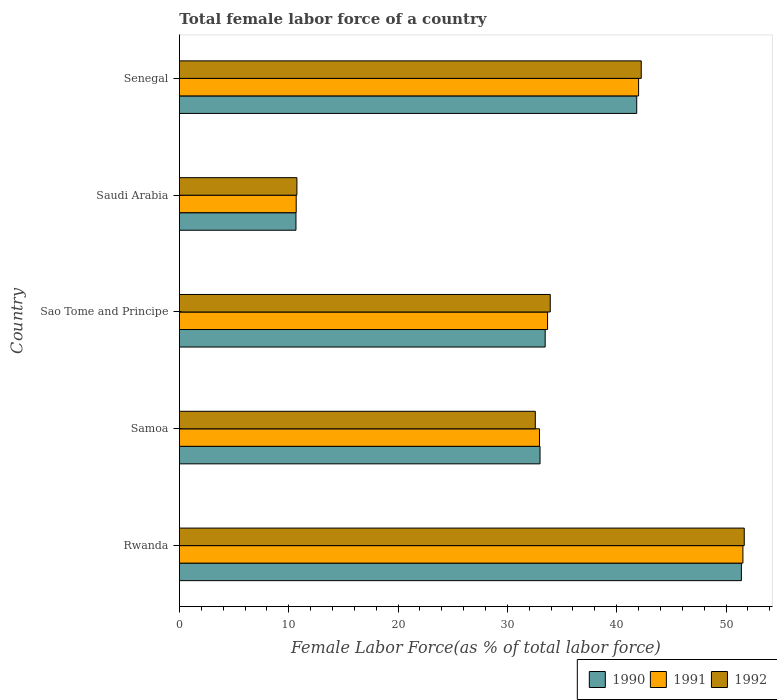How many different coloured bars are there?
Provide a short and direct response. 3. Are the number of bars per tick equal to the number of legend labels?
Your response must be concise. Yes. Are the number of bars on each tick of the Y-axis equal?
Your answer should be compact. Yes. What is the label of the 3rd group of bars from the top?
Ensure brevity in your answer.  Sao Tome and Principe. What is the percentage of female labor force in 1991 in Samoa?
Give a very brief answer. 32.94. Across all countries, what is the maximum percentage of female labor force in 1991?
Offer a very short reply. 51.55. Across all countries, what is the minimum percentage of female labor force in 1992?
Ensure brevity in your answer.  10.75. In which country was the percentage of female labor force in 1990 maximum?
Your answer should be very brief. Rwanda. In which country was the percentage of female labor force in 1992 minimum?
Your answer should be compact. Saudi Arabia. What is the total percentage of female labor force in 1992 in the graph?
Give a very brief answer. 171.13. What is the difference between the percentage of female labor force in 1991 in Samoa and that in Sao Tome and Principe?
Keep it short and to the point. -0.74. What is the difference between the percentage of female labor force in 1990 in Rwanda and the percentage of female labor force in 1992 in Samoa?
Your response must be concise. 18.85. What is the average percentage of female labor force in 1990 per country?
Offer a very short reply. 34.07. What is the difference between the percentage of female labor force in 1991 and percentage of female labor force in 1990 in Sao Tome and Principe?
Give a very brief answer. 0.22. In how many countries, is the percentage of female labor force in 1990 greater than 22 %?
Provide a short and direct response. 4. What is the ratio of the percentage of female labor force in 1991 in Samoa to that in Sao Tome and Principe?
Provide a succinct answer. 0.98. What is the difference between the highest and the second highest percentage of female labor force in 1991?
Offer a very short reply. 9.54. What is the difference between the highest and the lowest percentage of female labor force in 1990?
Keep it short and to the point. 40.74. In how many countries, is the percentage of female labor force in 1991 greater than the average percentage of female labor force in 1991 taken over all countries?
Offer a very short reply. 2. Is the sum of the percentage of female labor force in 1990 in Rwanda and Saudi Arabia greater than the maximum percentage of female labor force in 1991 across all countries?
Your answer should be compact. Yes. How many bars are there?
Offer a very short reply. 15. How many countries are there in the graph?
Provide a short and direct response. 5. What is the difference between two consecutive major ticks on the X-axis?
Provide a succinct answer. 10. What is the title of the graph?
Your response must be concise. Total female labor force of a country. Does "1983" appear as one of the legend labels in the graph?
Provide a short and direct response. No. What is the label or title of the X-axis?
Your answer should be compact. Female Labor Force(as % of total labor force). What is the Female Labor Force(as % of total labor force) in 1990 in Rwanda?
Your answer should be compact. 51.4. What is the Female Labor Force(as % of total labor force) in 1991 in Rwanda?
Your response must be concise. 51.55. What is the Female Labor Force(as % of total labor force) of 1992 in Rwanda?
Offer a terse response. 51.67. What is the Female Labor Force(as % of total labor force) of 1990 in Samoa?
Keep it short and to the point. 32.99. What is the Female Labor Force(as % of total labor force) of 1991 in Samoa?
Your answer should be compact. 32.94. What is the Female Labor Force(as % of total labor force) of 1992 in Samoa?
Keep it short and to the point. 32.55. What is the Female Labor Force(as % of total labor force) in 1990 in Sao Tome and Principe?
Your answer should be very brief. 33.46. What is the Female Labor Force(as % of total labor force) of 1991 in Sao Tome and Principe?
Your response must be concise. 33.67. What is the Female Labor Force(as % of total labor force) of 1992 in Sao Tome and Principe?
Offer a very short reply. 33.92. What is the Female Labor Force(as % of total labor force) of 1990 in Saudi Arabia?
Offer a terse response. 10.66. What is the Female Labor Force(as % of total labor force) of 1991 in Saudi Arabia?
Give a very brief answer. 10.68. What is the Female Labor Force(as % of total labor force) of 1992 in Saudi Arabia?
Provide a short and direct response. 10.75. What is the Female Labor Force(as % of total labor force) of 1990 in Senegal?
Your response must be concise. 41.83. What is the Female Labor Force(as % of total labor force) of 1991 in Senegal?
Your answer should be compact. 42. What is the Female Labor Force(as % of total labor force) in 1992 in Senegal?
Ensure brevity in your answer.  42.24. Across all countries, what is the maximum Female Labor Force(as % of total labor force) in 1990?
Offer a terse response. 51.4. Across all countries, what is the maximum Female Labor Force(as % of total labor force) of 1991?
Your response must be concise. 51.55. Across all countries, what is the maximum Female Labor Force(as % of total labor force) of 1992?
Provide a succinct answer. 51.67. Across all countries, what is the minimum Female Labor Force(as % of total labor force) in 1990?
Ensure brevity in your answer.  10.66. Across all countries, what is the minimum Female Labor Force(as % of total labor force) in 1991?
Your response must be concise. 10.68. Across all countries, what is the minimum Female Labor Force(as % of total labor force) in 1992?
Offer a terse response. 10.75. What is the total Female Labor Force(as % of total labor force) of 1990 in the graph?
Your response must be concise. 170.34. What is the total Female Labor Force(as % of total labor force) of 1991 in the graph?
Your answer should be compact. 170.84. What is the total Female Labor Force(as % of total labor force) of 1992 in the graph?
Ensure brevity in your answer.  171.13. What is the difference between the Female Labor Force(as % of total labor force) of 1990 in Rwanda and that in Samoa?
Provide a succinct answer. 18.42. What is the difference between the Female Labor Force(as % of total labor force) in 1991 in Rwanda and that in Samoa?
Your answer should be very brief. 18.61. What is the difference between the Female Labor Force(as % of total labor force) of 1992 in Rwanda and that in Samoa?
Provide a short and direct response. 19.11. What is the difference between the Female Labor Force(as % of total labor force) of 1990 in Rwanda and that in Sao Tome and Principe?
Provide a succinct answer. 17.95. What is the difference between the Female Labor Force(as % of total labor force) in 1991 in Rwanda and that in Sao Tome and Principe?
Provide a succinct answer. 17.87. What is the difference between the Female Labor Force(as % of total labor force) in 1992 in Rwanda and that in Sao Tome and Principe?
Your response must be concise. 17.75. What is the difference between the Female Labor Force(as % of total labor force) of 1990 in Rwanda and that in Saudi Arabia?
Your answer should be compact. 40.74. What is the difference between the Female Labor Force(as % of total labor force) of 1991 in Rwanda and that in Saudi Arabia?
Give a very brief answer. 40.86. What is the difference between the Female Labor Force(as % of total labor force) of 1992 in Rwanda and that in Saudi Arabia?
Keep it short and to the point. 40.92. What is the difference between the Female Labor Force(as % of total labor force) of 1990 in Rwanda and that in Senegal?
Offer a terse response. 9.57. What is the difference between the Female Labor Force(as % of total labor force) in 1991 in Rwanda and that in Senegal?
Provide a short and direct response. 9.54. What is the difference between the Female Labor Force(as % of total labor force) in 1992 in Rwanda and that in Senegal?
Ensure brevity in your answer.  9.42. What is the difference between the Female Labor Force(as % of total labor force) in 1990 in Samoa and that in Sao Tome and Principe?
Your response must be concise. -0.47. What is the difference between the Female Labor Force(as % of total labor force) of 1991 in Samoa and that in Sao Tome and Principe?
Your response must be concise. -0.74. What is the difference between the Female Labor Force(as % of total labor force) of 1992 in Samoa and that in Sao Tome and Principe?
Give a very brief answer. -1.37. What is the difference between the Female Labor Force(as % of total labor force) in 1990 in Samoa and that in Saudi Arabia?
Your response must be concise. 22.32. What is the difference between the Female Labor Force(as % of total labor force) in 1991 in Samoa and that in Saudi Arabia?
Your response must be concise. 22.26. What is the difference between the Female Labor Force(as % of total labor force) in 1992 in Samoa and that in Saudi Arabia?
Ensure brevity in your answer.  21.81. What is the difference between the Female Labor Force(as % of total labor force) of 1990 in Samoa and that in Senegal?
Make the answer very short. -8.85. What is the difference between the Female Labor Force(as % of total labor force) in 1991 in Samoa and that in Senegal?
Provide a short and direct response. -9.06. What is the difference between the Female Labor Force(as % of total labor force) of 1992 in Samoa and that in Senegal?
Ensure brevity in your answer.  -9.69. What is the difference between the Female Labor Force(as % of total labor force) of 1990 in Sao Tome and Principe and that in Saudi Arabia?
Ensure brevity in your answer.  22.79. What is the difference between the Female Labor Force(as % of total labor force) of 1991 in Sao Tome and Principe and that in Saudi Arabia?
Offer a terse response. 22.99. What is the difference between the Female Labor Force(as % of total labor force) of 1992 in Sao Tome and Principe and that in Saudi Arabia?
Your response must be concise. 23.17. What is the difference between the Female Labor Force(as % of total labor force) of 1990 in Sao Tome and Principe and that in Senegal?
Make the answer very short. -8.38. What is the difference between the Female Labor Force(as % of total labor force) in 1991 in Sao Tome and Principe and that in Senegal?
Make the answer very short. -8.33. What is the difference between the Female Labor Force(as % of total labor force) of 1992 in Sao Tome and Principe and that in Senegal?
Your answer should be very brief. -8.32. What is the difference between the Female Labor Force(as % of total labor force) of 1990 in Saudi Arabia and that in Senegal?
Give a very brief answer. -31.17. What is the difference between the Female Labor Force(as % of total labor force) in 1991 in Saudi Arabia and that in Senegal?
Your answer should be very brief. -31.32. What is the difference between the Female Labor Force(as % of total labor force) in 1992 in Saudi Arabia and that in Senegal?
Ensure brevity in your answer.  -31.5. What is the difference between the Female Labor Force(as % of total labor force) of 1990 in Rwanda and the Female Labor Force(as % of total labor force) of 1991 in Samoa?
Provide a succinct answer. 18.47. What is the difference between the Female Labor Force(as % of total labor force) of 1990 in Rwanda and the Female Labor Force(as % of total labor force) of 1992 in Samoa?
Your answer should be very brief. 18.85. What is the difference between the Female Labor Force(as % of total labor force) in 1991 in Rwanda and the Female Labor Force(as % of total labor force) in 1992 in Samoa?
Your answer should be compact. 18.99. What is the difference between the Female Labor Force(as % of total labor force) in 1990 in Rwanda and the Female Labor Force(as % of total labor force) in 1991 in Sao Tome and Principe?
Make the answer very short. 17.73. What is the difference between the Female Labor Force(as % of total labor force) in 1990 in Rwanda and the Female Labor Force(as % of total labor force) in 1992 in Sao Tome and Principe?
Your answer should be very brief. 17.48. What is the difference between the Female Labor Force(as % of total labor force) in 1991 in Rwanda and the Female Labor Force(as % of total labor force) in 1992 in Sao Tome and Principe?
Offer a very short reply. 17.62. What is the difference between the Female Labor Force(as % of total labor force) of 1990 in Rwanda and the Female Labor Force(as % of total labor force) of 1991 in Saudi Arabia?
Offer a very short reply. 40.72. What is the difference between the Female Labor Force(as % of total labor force) in 1990 in Rwanda and the Female Labor Force(as % of total labor force) in 1992 in Saudi Arabia?
Offer a very short reply. 40.66. What is the difference between the Female Labor Force(as % of total labor force) of 1991 in Rwanda and the Female Labor Force(as % of total labor force) of 1992 in Saudi Arabia?
Your response must be concise. 40.8. What is the difference between the Female Labor Force(as % of total labor force) of 1990 in Rwanda and the Female Labor Force(as % of total labor force) of 1991 in Senegal?
Your response must be concise. 9.4. What is the difference between the Female Labor Force(as % of total labor force) in 1990 in Rwanda and the Female Labor Force(as % of total labor force) in 1992 in Senegal?
Your answer should be very brief. 9.16. What is the difference between the Female Labor Force(as % of total labor force) of 1991 in Rwanda and the Female Labor Force(as % of total labor force) of 1992 in Senegal?
Your answer should be compact. 9.3. What is the difference between the Female Labor Force(as % of total labor force) of 1990 in Samoa and the Female Labor Force(as % of total labor force) of 1991 in Sao Tome and Principe?
Your response must be concise. -0.69. What is the difference between the Female Labor Force(as % of total labor force) in 1990 in Samoa and the Female Labor Force(as % of total labor force) in 1992 in Sao Tome and Principe?
Offer a terse response. -0.93. What is the difference between the Female Labor Force(as % of total labor force) of 1991 in Samoa and the Female Labor Force(as % of total labor force) of 1992 in Sao Tome and Principe?
Make the answer very short. -0.98. What is the difference between the Female Labor Force(as % of total labor force) in 1990 in Samoa and the Female Labor Force(as % of total labor force) in 1991 in Saudi Arabia?
Ensure brevity in your answer.  22.3. What is the difference between the Female Labor Force(as % of total labor force) of 1990 in Samoa and the Female Labor Force(as % of total labor force) of 1992 in Saudi Arabia?
Make the answer very short. 22.24. What is the difference between the Female Labor Force(as % of total labor force) in 1991 in Samoa and the Female Labor Force(as % of total labor force) in 1992 in Saudi Arabia?
Your response must be concise. 22.19. What is the difference between the Female Labor Force(as % of total labor force) of 1990 in Samoa and the Female Labor Force(as % of total labor force) of 1991 in Senegal?
Provide a succinct answer. -9.01. What is the difference between the Female Labor Force(as % of total labor force) in 1990 in Samoa and the Female Labor Force(as % of total labor force) in 1992 in Senegal?
Ensure brevity in your answer.  -9.26. What is the difference between the Female Labor Force(as % of total labor force) in 1991 in Samoa and the Female Labor Force(as % of total labor force) in 1992 in Senegal?
Offer a very short reply. -9.31. What is the difference between the Female Labor Force(as % of total labor force) in 1990 in Sao Tome and Principe and the Female Labor Force(as % of total labor force) in 1991 in Saudi Arabia?
Offer a very short reply. 22.77. What is the difference between the Female Labor Force(as % of total labor force) of 1990 in Sao Tome and Principe and the Female Labor Force(as % of total labor force) of 1992 in Saudi Arabia?
Give a very brief answer. 22.71. What is the difference between the Female Labor Force(as % of total labor force) of 1991 in Sao Tome and Principe and the Female Labor Force(as % of total labor force) of 1992 in Saudi Arabia?
Provide a succinct answer. 22.93. What is the difference between the Female Labor Force(as % of total labor force) in 1990 in Sao Tome and Principe and the Female Labor Force(as % of total labor force) in 1991 in Senegal?
Provide a succinct answer. -8.55. What is the difference between the Female Labor Force(as % of total labor force) of 1990 in Sao Tome and Principe and the Female Labor Force(as % of total labor force) of 1992 in Senegal?
Your response must be concise. -8.79. What is the difference between the Female Labor Force(as % of total labor force) in 1991 in Sao Tome and Principe and the Female Labor Force(as % of total labor force) in 1992 in Senegal?
Make the answer very short. -8.57. What is the difference between the Female Labor Force(as % of total labor force) in 1990 in Saudi Arabia and the Female Labor Force(as % of total labor force) in 1991 in Senegal?
Your response must be concise. -31.34. What is the difference between the Female Labor Force(as % of total labor force) of 1990 in Saudi Arabia and the Female Labor Force(as % of total labor force) of 1992 in Senegal?
Your answer should be compact. -31.58. What is the difference between the Female Labor Force(as % of total labor force) in 1991 in Saudi Arabia and the Female Labor Force(as % of total labor force) in 1992 in Senegal?
Give a very brief answer. -31.56. What is the average Female Labor Force(as % of total labor force) of 1990 per country?
Provide a short and direct response. 34.07. What is the average Female Labor Force(as % of total labor force) of 1991 per country?
Give a very brief answer. 34.17. What is the average Female Labor Force(as % of total labor force) in 1992 per country?
Provide a short and direct response. 34.23. What is the difference between the Female Labor Force(as % of total labor force) in 1990 and Female Labor Force(as % of total labor force) in 1991 in Rwanda?
Offer a very short reply. -0.14. What is the difference between the Female Labor Force(as % of total labor force) of 1990 and Female Labor Force(as % of total labor force) of 1992 in Rwanda?
Make the answer very short. -0.26. What is the difference between the Female Labor Force(as % of total labor force) of 1991 and Female Labor Force(as % of total labor force) of 1992 in Rwanda?
Make the answer very short. -0.12. What is the difference between the Female Labor Force(as % of total labor force) of 1990 and Female Labor Force(as % of total labor force) of 1991 in Samoa?
Make the answer very short. 0.05. What is the difference between the Female Labor Force(as % of total labor force) of 1990 and Female Labor Force(as % of total labor force) of 1992 in Samoa?
Give a very brief answer. 0.43. What is the difference between the Female Labor Force(as % of total labor force) of 1991 and Female Labor Force(as % of total labor force) of 1992 in Samoa?
Provide a succinct answer. 0.38. What is the difference between the Female Labor Force(as % of total labor force) of 1990 and Female Labor Force(as % of total labor force) of 1991 in Sao Tome and Principe?
Provide a short and direct response. -0.22. What is the difference between the Female Labor Force(as % of total labor force) in 1990 and Female Labor Force(as % of total labor force) in 1992 in Sao Tome and Principe?
Ensure brevity in your answer.  -0.46. What is the difference between the Female Labor Force(as % of total labor force) of 1991 and Female Labor Force(as % of total labor force) of 1992 in Sao Tome and Principe?
Your response must be concise. -0.25. What is the difference between the Female Labor Force(as % of total labor force) of 1990 and Female Labor Force(as % of total labor force) of 1991 in Saudi Arabia?
Your answer should be very brief. -0.02. What is the difference between the Female Labor Force(as % of total labor force) in 1990 and Female Labor Force(as % of total labor force) in 1992 in Saudi Arabia?
Offer a very short reply. -0.08. What is the difference between the Female Labor Force(as % of total labor force) in 1991 and Female Labor Force(as % of total labor force) in 1992 in Saudi Arabia?
Your answer should be very brief. -0.06. What is the difference between the Female Labor Force(as % of total labor force) of 1990 and Female Labor Force(as % of total labor force) of 1991 in Senegal?
Ensure brevity in your answer.  -0.17. What is the difference between the Female Labor Force(as % of total labor force) of 1990 and Female Labor Force(as % of total labor force) of 1992 in Senegal?
Your response must be concise. -0.41. What is the difference between the Female Labor Force(as % of total labor force) of 1991 and Female Labor Force(as % of total labor force) of 1992 in Senegal?
Your answer should be very brief. -0.24. What is the ratio of the Female Labor Force(as % of total labor force) in 1990 in Rwanda to that in Samoa?
Offer a very short reply. 1.56. What is the ratio of the Female Labor Force(as % of total labor force) in 1991 in Rwanda to that in Samoa?
Give a very brief answer. 1.56. What is the ratio of the Female Labor Force(as % of total labor force) in 1992 in Rwanda to that in Samoa?
Make the answer very short. 1.59. What is the ratio of the Female Labor Force(as % of total labor force) of 1990 in Rwanda to that in Sao Tome and Principe?
Ensure brevity in your answer.  1.54. What is the ratio of the Female Labor Force(as % of total labor force) in 1991 in Rwanda to that in Sao Tome and Principe?
Provide a short and direct response. 1.53. What is the ratio of the Female Labor Force(as % of total labor force) in 1992 in Rwanda to that in Sao Tome and Principe?
Your answer should be compact. 1.52. What is the ratio of the Female Labor Force(as % of total labor force) of 1990 in Rwanda to that in Saudi Arabia?
Make the answer very short. 4.82. What is the ratio of the Female Labor Force(as % of total labor force) in 1991 in Rwanda to that in Saudi Arabia?
Your answer should be compact. 4.83. What is the ratio of the Female Labor Force(as % of total labor force) in 1992 in Rwanda to that in Saudi Arabia?
Keep it short and to the point. 4.81. What is the ratio of the Female Labor Force(as % of total labor force) of 1990 in Rwanda to that in Senegal?
Make the answer very short. 1.23. What is the ratio of the Female Labor Force(as % of total labor force) in 1991 in Rwanda to that in Senegal?
Your response must be concise. 1.23. What is the ratio of the Female Labor Force(as % of total labor force) in 1992 in Rwanda to that in Senegal?
Your response must be concise. 1.22. What is the ratio of the Female Labor Force(as % of total labor force) of 1991 in Samoa to that in Sao Tome and Principe?
Ensure brevity in your answer.  0.98. What is the ratio of the Female Labor Force(as % of total labor force) in 1992 in Samoa to that in Sao Tome and Principe?
Provide a succinct answer. 0.96. What is the ratio of the Female Labor Force(as % of total labor force) of 1990 in Samoa to that in Saudi Arabia?
Offer a very short reply. 3.09. What is the ratio of the Female Labor Force(as % of total labor force) in 1991 in Samoa to that in Saudi Arabia?
Offer a terse response. 3.08. What is the ratio of the Female Labor Force(as % of total labor force) in 1992 in Samoa to that in Saudi Arabia?
Provide a succinct answer. 3.03. What is the ratio of the Female Labor Force(as % of total labor force) in 1990 in Samoa to that in Senegal?
Provide a short and direct response. 0.79. What is the ratio of the Female Labor Force(as % of total labor force) in 1991 in Samoa to that in Senegal?
Ensure brevity in your answer.  0.78. What is the ratio of the Female Labor Force(as % of total labor force) of 1992 in Samoa to that in Senegal?
Your answer should be very brief. 0.77. What is the ratio of the Female Labor Force(as % of total labor force) of 1990 in Sao Tome and Principe to that in Saudi Arabia?
Provide a short and direct response. 3.14. What is the ratio of the Female Labor Force(as % of total labor force) of 1991 in Sao Tome and Principe to that in Saudi Arabia?
Give a very brief answer. 3.15. What is the ratio of the Female Labor Force(as % of total labor force) in 1992 in Sao Tome and Principe to that in Saudi Arabia?
Offer a terse response. 3.16. What is the ratio of the Female Labor Force(as % of total labor force) in 1990 in Sao Tome and Principe to that in Senegal?
Your answer should be very brief. 0.8. What is the ratio of the Female Labor Force(as % of total labor force) of 1991 in Sao Tome and Principe to that in Senegal?
Your answer should be very brief. 0.8. What is the ratio of the Female Labor Force(as % of total labor force) in 1992 in Sao Tome and Principe to that in Senegal?
Offer a very short reply. 0.8. What is the ratio of the Female Labor Force(as % of total labor force) of 1990 in Saudi Arabia to that in Senegal?
Make the answer very short. 0.25. What is the ratio of the Female Labor Force(as % of total labor force) of 1991 in Saudi Arabia to that in Senegal?
Your response must be concise. 0.25. What is the ratio of the Female Labor Force(as % of total labor force) in 1992 in Saudi Arabia to that in Senegal?
Give a very brief answer. 0.25. What is the difference between the highest and the second highest Female Labor Force(as % of total labor force) of 1990?
Provide a succinct answer. 9.57. What is the difference between the highest and the second highest Female Labor Force(as % of total labor force) in 1991?
Provide a short and direct response. 9.54. What is the difference between the highest and the second highest Female Labor Force(as % of total labor force) of 1992?
Provide a succinct answer. 9.42. What is the difference between the highest and the lowest Female Labor Force(as % of total labor force) in 1990?
Offer a terse response. 40.74. What is the difference between the highest and the lowest Female Labor Force(as % of total labor force) of 1991?
Give a very brief answer. 40.86. What is the difference between the highest and the lowest Female Labor Force(as % of total labor force) in 1992?
Make the answer very short. 40.92. 